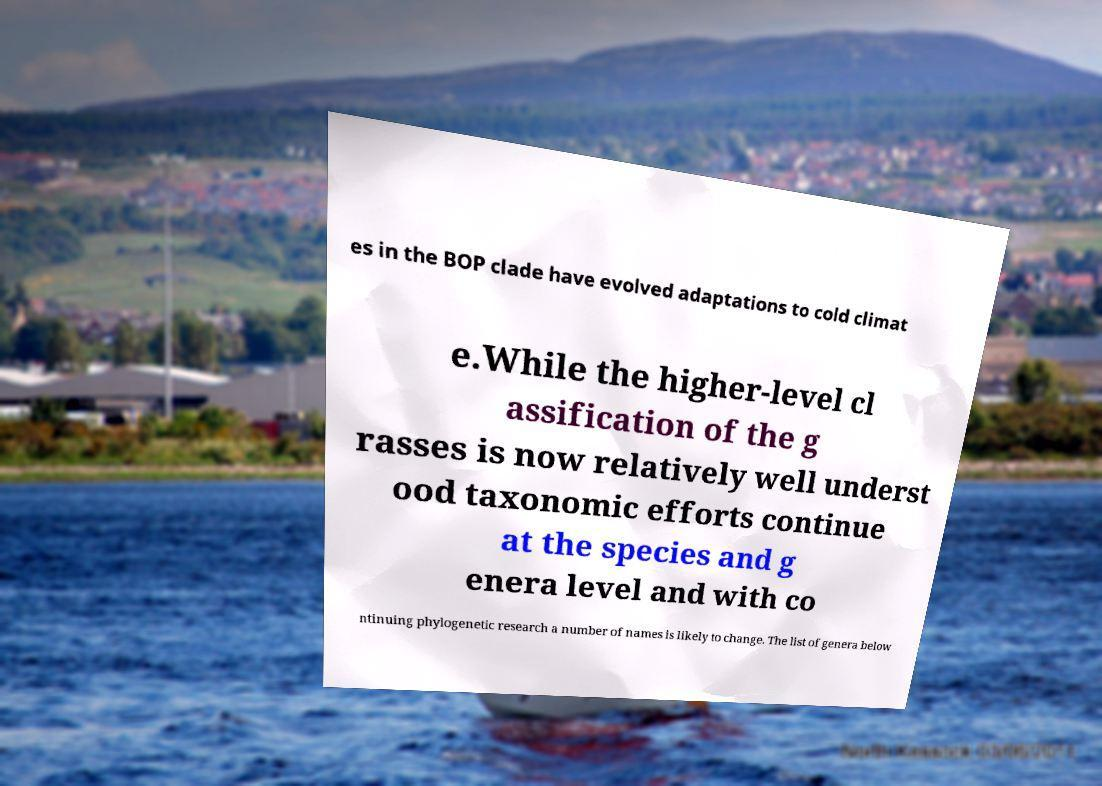Please identify and transcribe the text found in this image. es in the BOP clade have evolved adaptations to cold climat e.While the higher-level cl assification of the g rasses is now relatively well underst ood taxonomic efforts continue at the species and g enera level and with co ntinuing phylogenetic research a number of names is likely to change. The list of genera below 